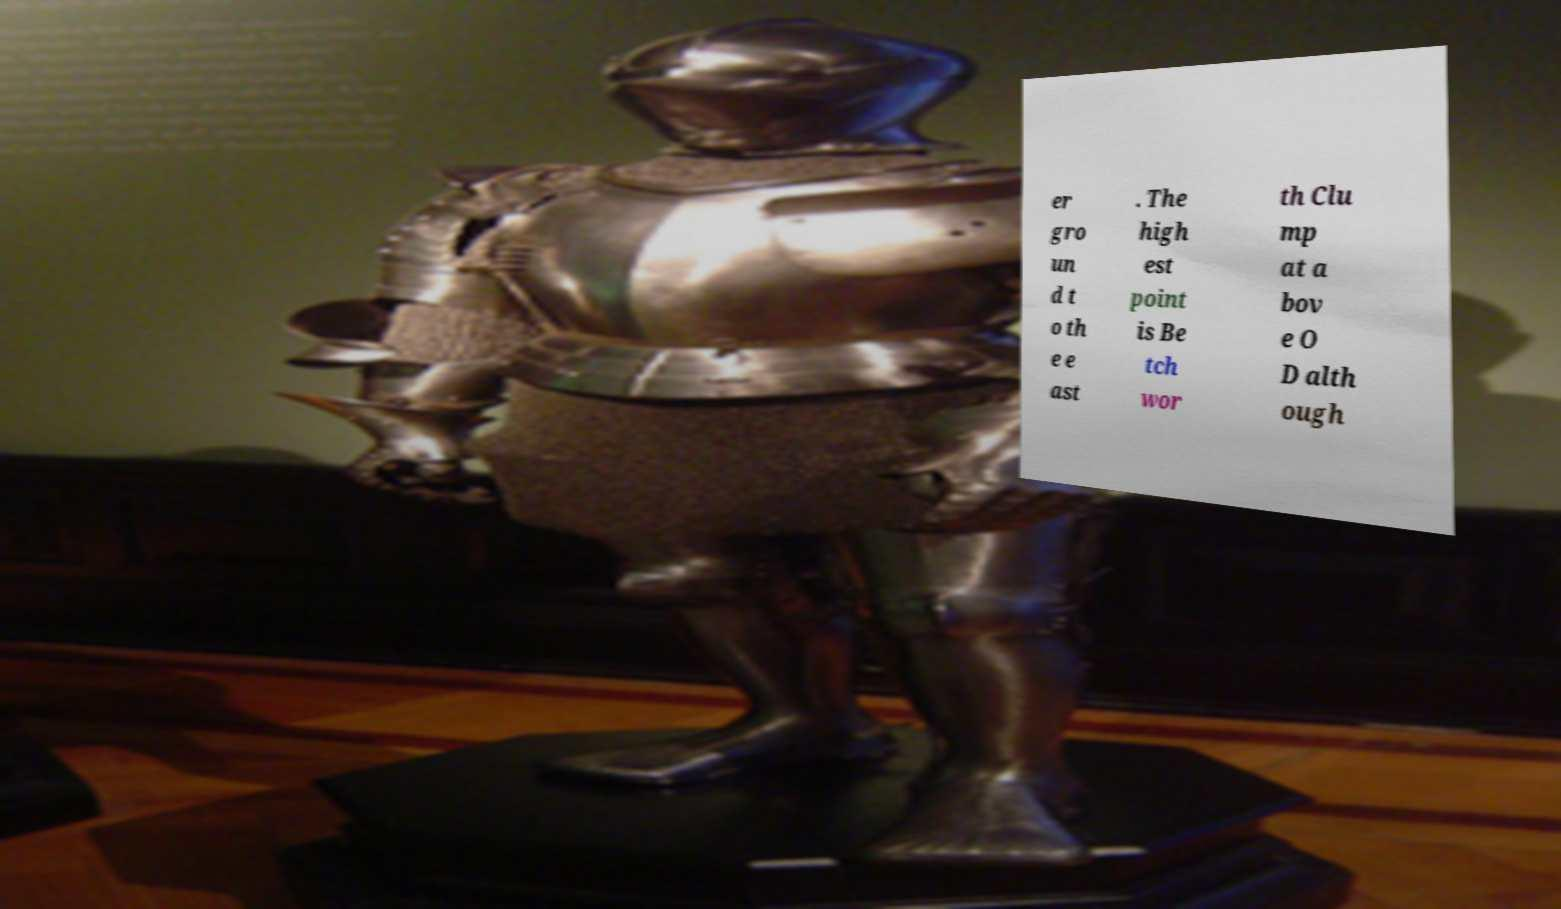What messages or text are displayed in this image? I need them in a readable, typed format. er gro un d t o th e e ast . The high est point is Be tch wor th Clu mp at a bov e O D alth ough 